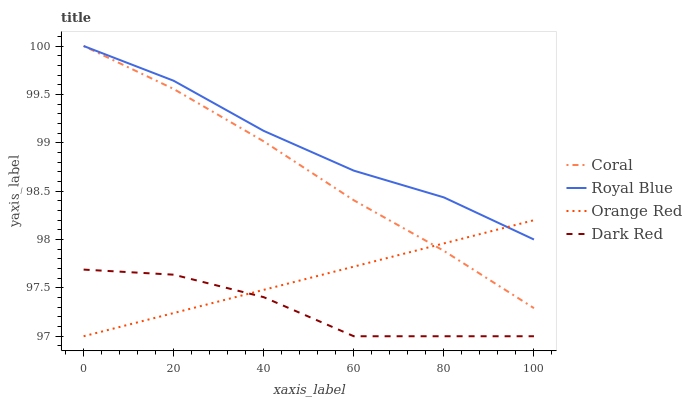Does Dark Red have the minimum area under the curve?
Answer yes or no. Yes. Does Royal Blue have the maximum area under the curve?
Answer yes or no. Yes. Does Coral have the minimum area under the curve?
Answer yes or no. No. Does Coral have the maximum area under the curve?
Answer yes or no. No. Is Orange Red the smoothest?
Answer yes or no. Yes. Is Dark Red the roughest?
Answer yes or no. Yes. Is Coral the smoothest?
Answer yes or no. No. Is Coral the roughest?
Answer yes or no. No. Does Coral have the lowest value?
Answer yes or no. No. Does Coral have the highest value?
Answer yes or no. Yes. Does Orange Red have the highest value?
Answer yes or no. No. Is Dark Red less than Royal Blue?
Answer yes or no. Yes. Is Royal Blue greater than Dark Red?
Answer yes or no. Yes. Does Coral intersect Royal Blue?
Answer yes or no. Yes. Is Coral less than Royal Blue?
Answer yes or no. No. Is Coral greater than Royal Blue?
Answer yes or no. No. Does Dark Red intersect Royal Blue?
Answer yes or no. No. 